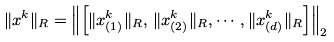<formula> <loc_0><loc_0><loc_500><loc_500>\| { x } ^ { k } \| _ { R } = \left \| \left [ \| { x } ^ { k } _ { ( 1 ) } \| _ { R } , \, \| { x } ^ { k } _ { ( 2 ) } \| _ { R } , \cdots , \| { x } ^ { k } _ { ( d ) } \| _ { R } \right ] \right \| _ { 2 }</formula> 